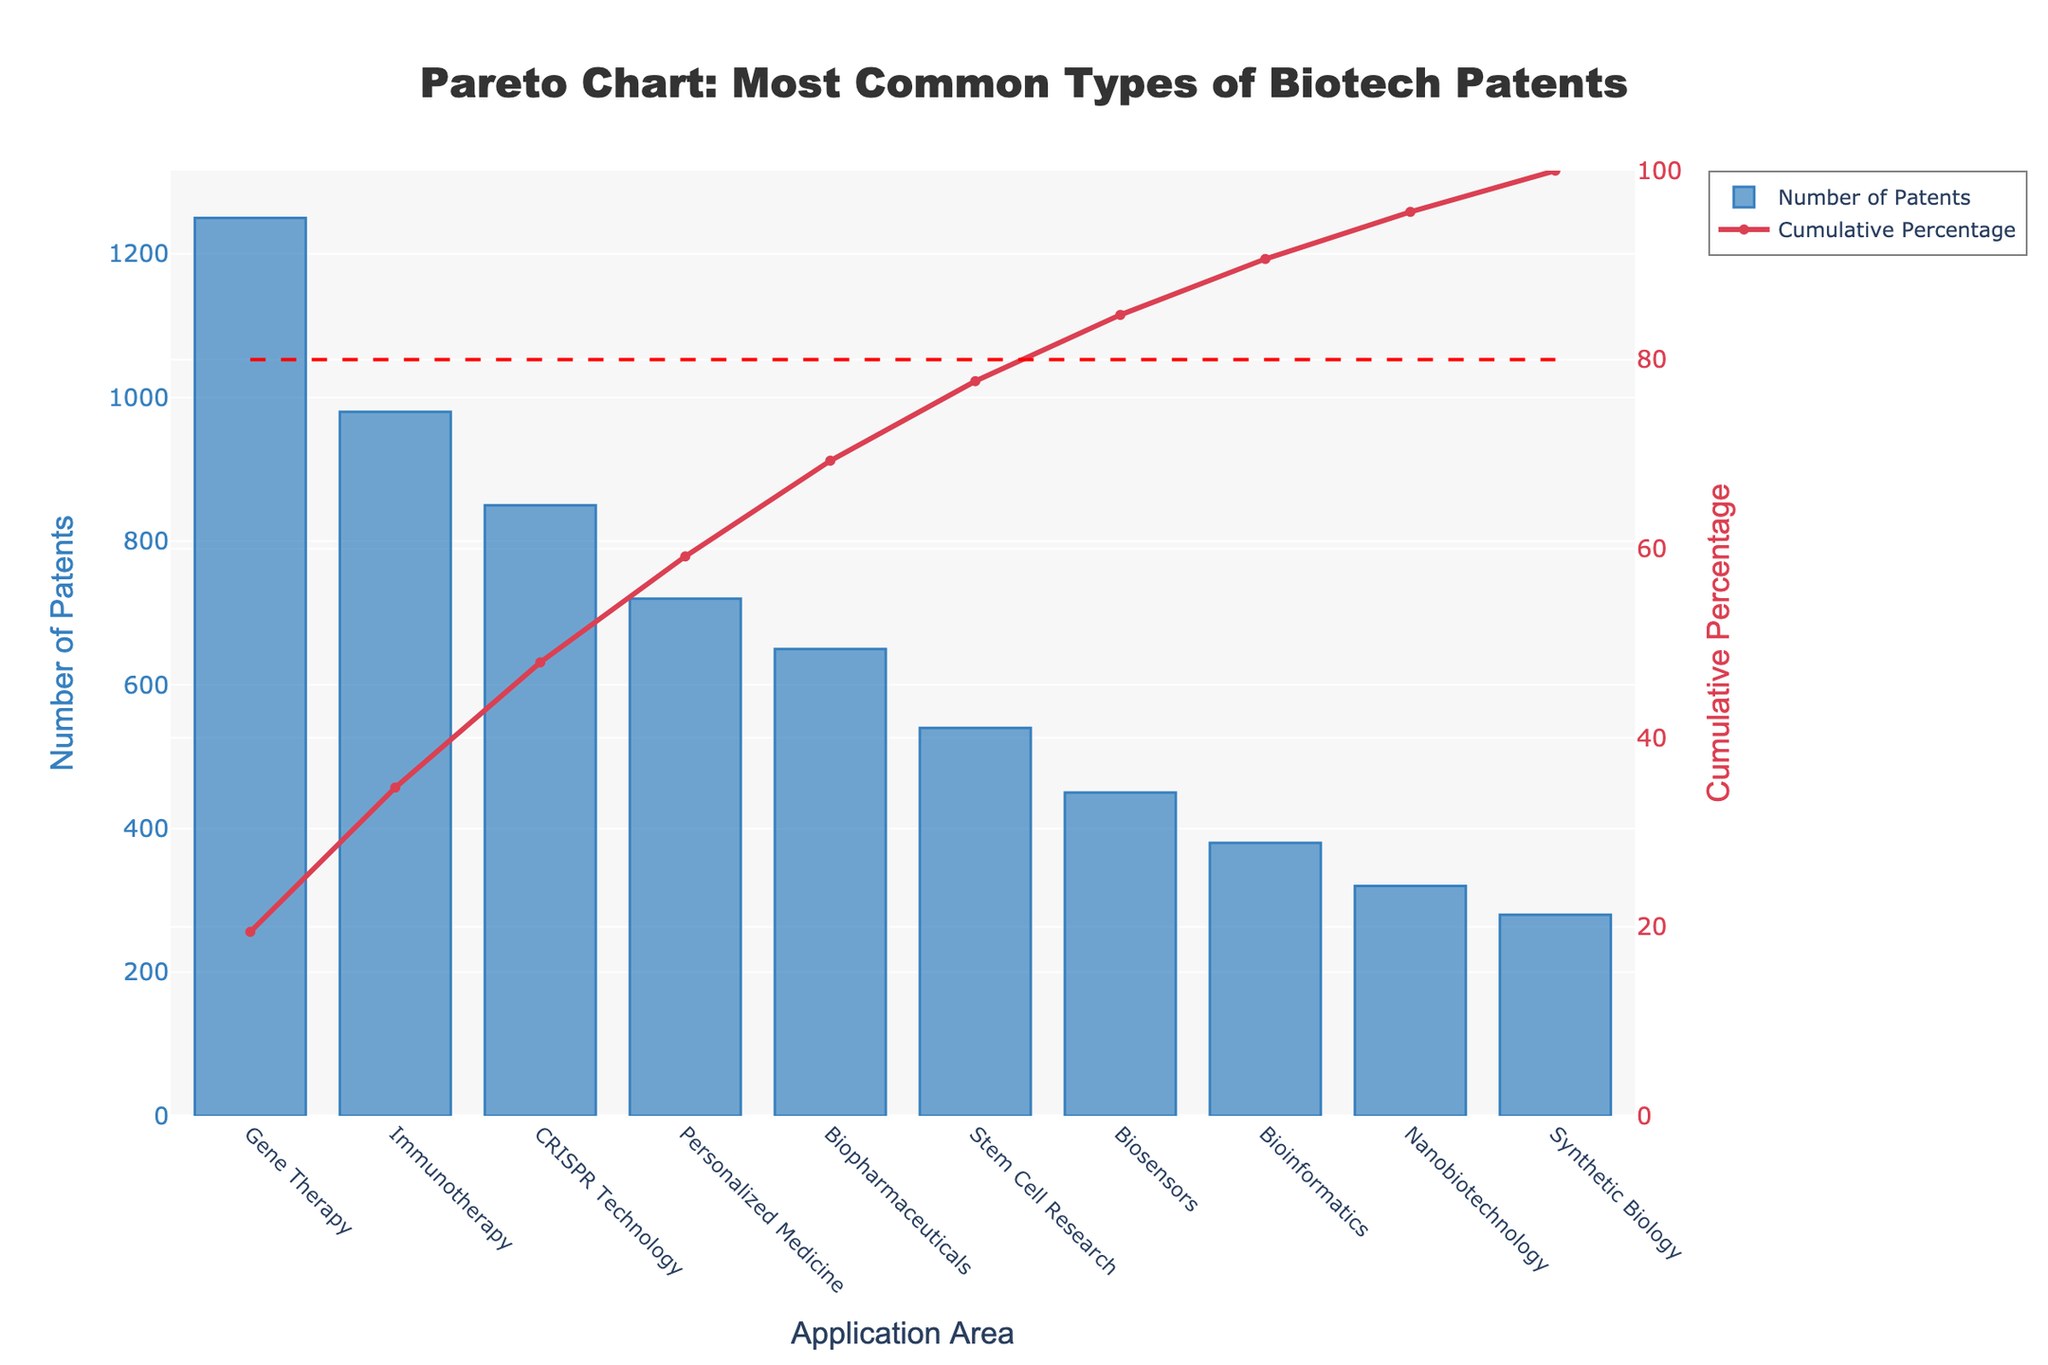Which application area has the highest number of biotech patents? The figure lists the number of patents for various application areas, and by looking at the bar heights, the highest bar represents the application area with the most patents.
Answer: Gene Therapy What's the total number of patents accounted for by the top three application areas? To find this, we add the number of patents for the top three application areas: Gene Therapy (1250), Immunotherapy (980), and CRISPR Technology (850). Adding these gives 1250 + 980 + 850 = 3080.
Answer: 3080 Which application area reaches the 80% cumulative percentage mark on the chart? The cumulative percentage line is plotted on the chart, and we need to identify the application area where the cumulative percentage intersects the 80% horizontal line.
Answer: Personalized Medicine How many more patents does Gene Therapy have compared to Stem Cell Research? Find the number of patents for both Gene Therapy (1250) and Stem Cell Research (540), then subtract the smaller number from the larger one: 1250 - 540 = 710.
Answer: 710 What's the cumulative percentage after the first four application areas? The cumulative percentages for the first four application areas can be summed up: 27.55% + 49.13% + 68.83% + 84.63%. This equals approximately 84.63%.
Answer: 84.63% Which application areas make up the top 50% of cumulative patents? By tracking the cumulative percentage, we find that Gene Therapy, Immunotherapy, and CRISPR Technology together exceed 50%. Therefore, these three make up the top 50%.
Answer: Gene Therapy, Immunotherapy, and CRISPR Technology What's the difference in the number of patents between the second and fifth most common application areas? Immunotherapy has 980 patents and Biopharmaceuticals has 650. The difference is 980 - 650 = 330.
Answer: 330 Which application area has the fewest number of patents? By looking at the shortest bar in the bar chart, we can identify that Synthetic Biology has the fewest patents.
Answer: Synthetic Biology How many application areas have a cumulative percentage of 75% or more? By following the cumulative percentage line, we count how many application areas it covers once it hits 75%. From the chart, it starts covering after the fourth area.
Answer: 4 What is the range of the number of patents filed among the application areas? The range is calculated by subtracting the smallest number of patents (280 for Synthetic Biology) from the largest number (1250 for Gene Therapy), resulting in 1250 - 280 = 970.
Answer: 970 